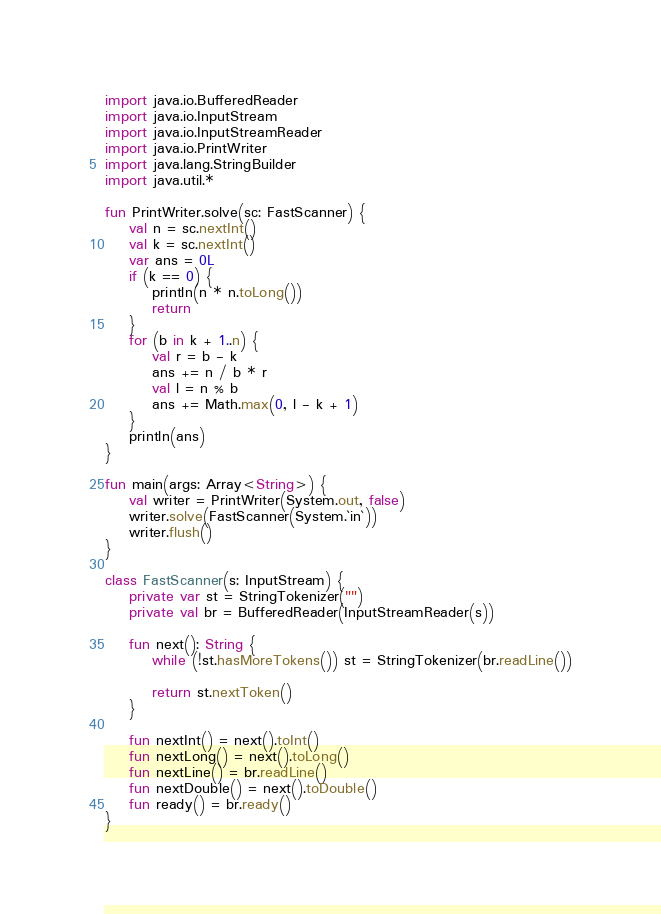<code> <loc_0><loc_0><loc_500><loc_500><_Kotlin_>import java.io.BufferedReader
import java.io.InputStream
import java.io.InputStreamReader
import java.io.PrintWriter
import java.lang.StringBuilder
import java.util.*

fun PrintWriter.solve(sc: FastScanner) {
    val n = sc.nextInt()
    val k = sc.nextInt()
    var ans = 0L
    if (k == 0) {
        println(n * n.toLong())
        return
    }
    for (b in k + 1..n) {
        val r = b - k
        ans += n / b * r
        val l = n % b
        ans += Math.max(0, l - k + 1)
    }
    println(ans)
}

fun main(args: Array<String>) {
    val writer = PrintWriter(System.out, false)
    writer.solve(FastScanner(System.`in`))
    writer.flush()
}

class FastScanner(s: InputStream) {
    private var st = StringTokenizer("")
    private val br = BufferedReader(InputStreamReader(s))

    fun next(): String {
        while (!st.hasMoreTokens()) st = StringTokenizer(br.readLine())

        return st.nextToken()
    }

    fun nextInt() = next().toInt()
    fun nextLong() = next().toLong()
    fun nextLine() = br.readLine()
    fun nextDouble() = next().toDouble()
    fun ready() = br.ready()
}
</code> 